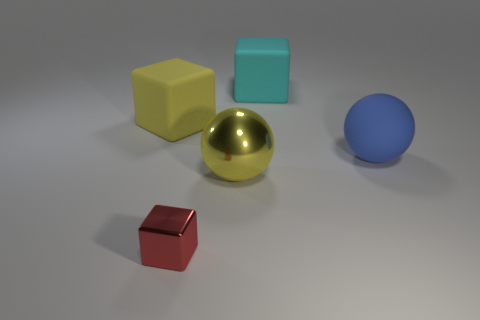Add 3 yellow rubber blocks. How many objects exist? 8 Subtract all spheres. How many objects are left? 3 Add 5 yellow spheres. How many yellow spheres are left? 6 Add 1 small cyan matte balls. How many small cyan matte balls exist? 1 Subtract 0 purple spheres. How many objects are left? 5 Subtract all big matte blocks. Subtract all cubes. How many objects are left? 0 